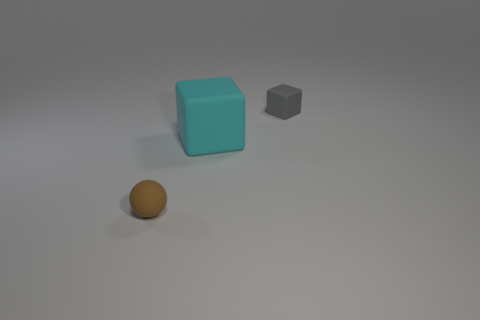Add 3 green metallic cylinders. How many objects exist? 6 Subtract all blocks. How many objects are left? 1 Subtract 0 blue balls. How many objects are left? 3 Subtract all small rubber blocks. Subtract all large rubber things. How many objects are left? 1 Add 2 gray rubber objects. How many gray rubber objects are left? 3 Add 1 big matte cubes. How many big matte cubes exist? 2 